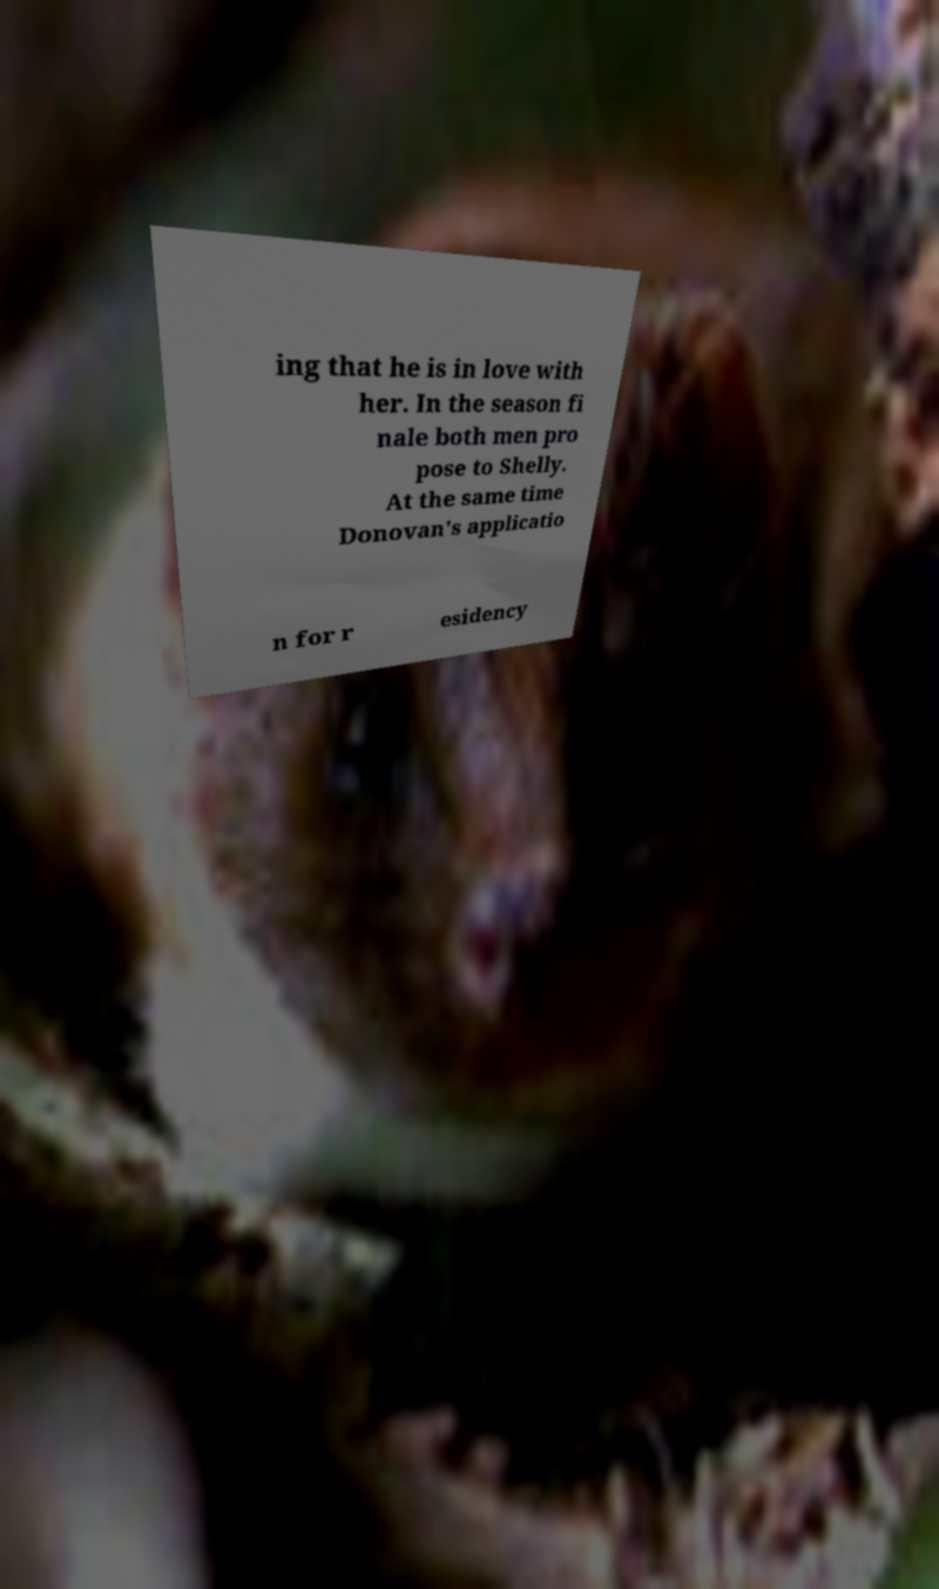Please read and relay the text visible in this image. What does it say? ing that he is in love with her. In the season fi nale both men pro pose to Shelly. At the same time Donovan's applicatio n for r esidency 